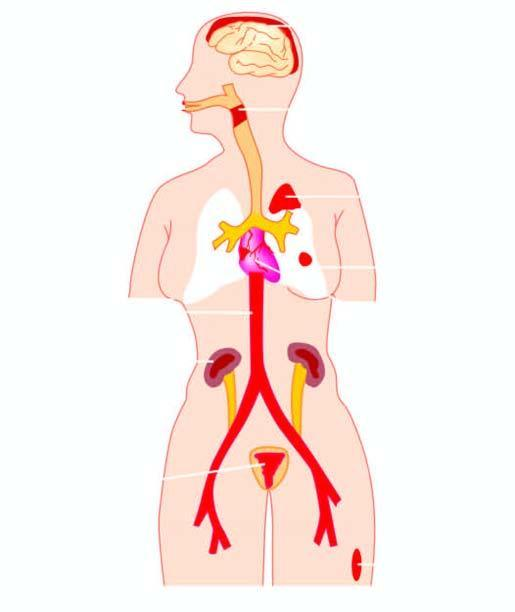what is caused by streptococci?
Answer the question using a single word or phrase. Diseases 